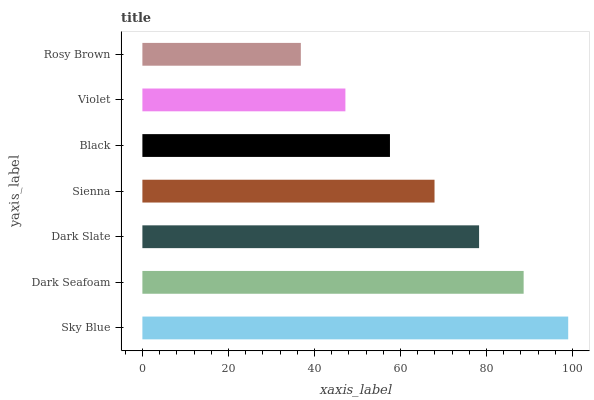Is Rosy Brown the minimum?
Answer yes or no. Yes. Is Sky Blue the maximum?
Answer yes or no. Yes. Is Dark Seafoam the minimum?
Answer yes or no. No. Is Dark Seafoam the maximum?
Answer yes or no. No. Is Sky Blue greater than Dark Seafoam?
Answer yes or no. Yes. Is Dark Seafoam less than Sky Blue?
Answer yes or no. Yes. Is Dark Seafoam greater than Sky Blue?
Answer yes or no. No. Is Sky Blue less than Dark Seafoam?
Answer yes or no. No. Is Sienna the high median?
Answer yes or no. Yes. Is Sienna the low median?
Answer yes or no. Yes. Is Dark Seafoam the high median?
Answer yes or no. No. Is Black the low median?
Answer yes or no. No. 